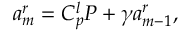Convert formula to latex. <formula><loc_0><loc_0><loc_500><loc_500>a _ { m } ^ { r } = C _ { p } ^ { l } P + \gamma a _ { m - 1 } ^ { r } ,</formula> 